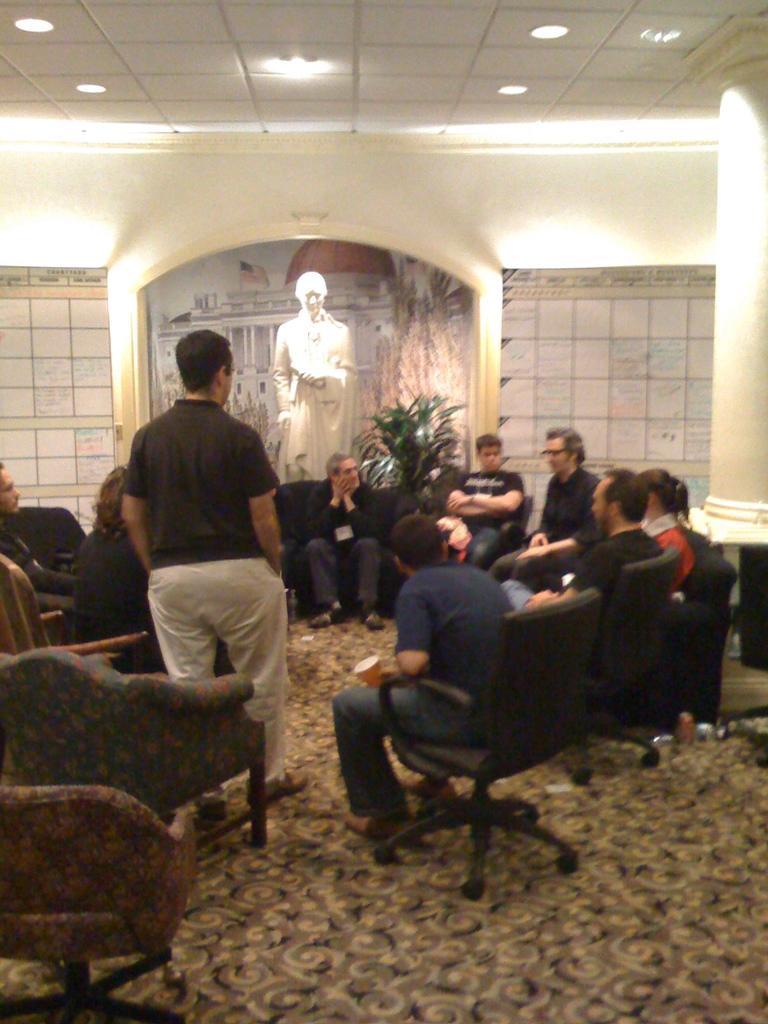How would you summarize this image in a sentence or two? There are group of people sitting on the chair and a man is standing on the floor. Behind them there is a plant,statue and wall. On the rooftop there are lights. 